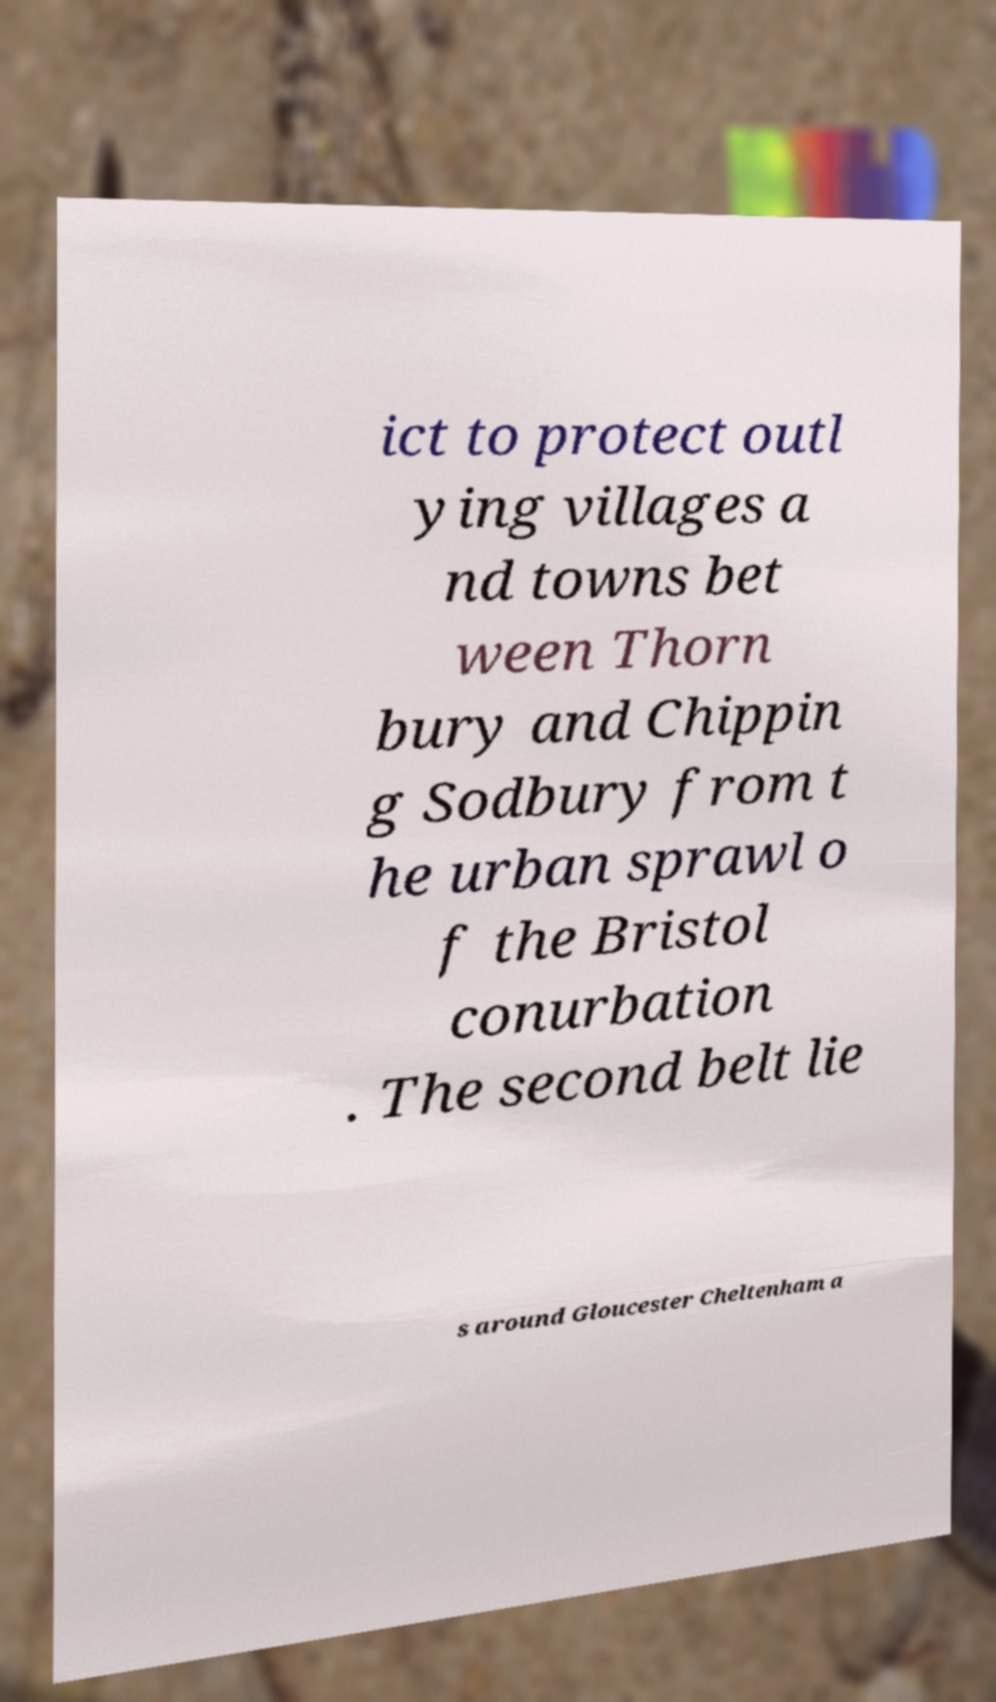Please read and relay the text visible in this image. What does it say? ict to protect outl ying villages a nd towns bet ween Thorn bury and Chippin g Sodbury from t he urban sprawl o f the Bristol conurbation . The second belt lie s around Gloucester Cheltenham a 